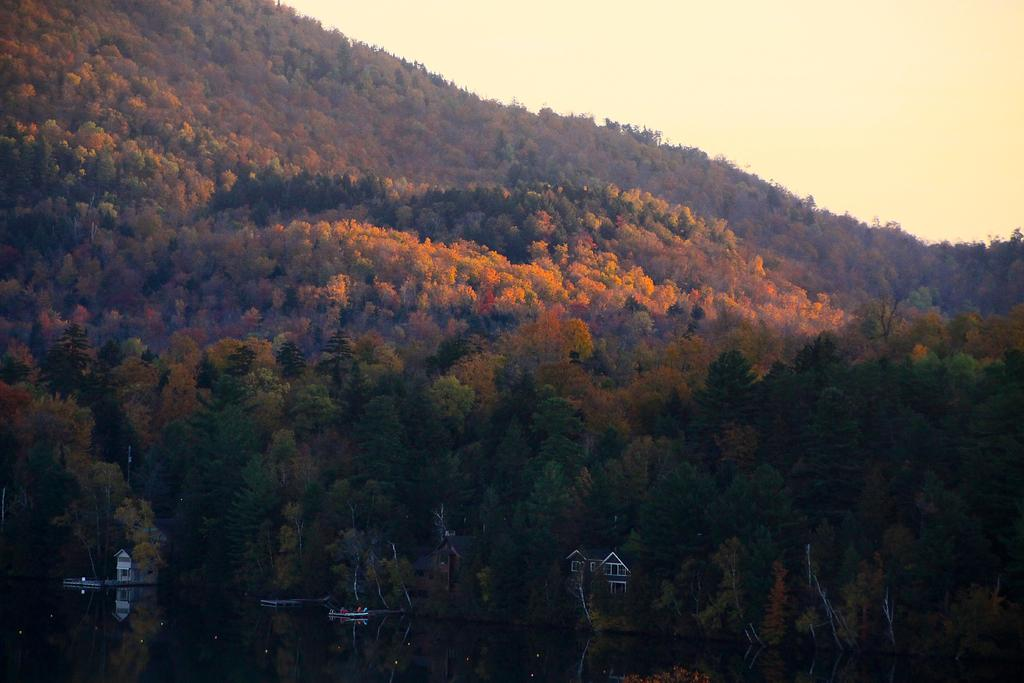What body of water is present in the image? There is a lake in the picture. What is located in the lake? There is a boat in the lake. What structures can be seen in the image? There are buildings in the picture. What type of vegetation is present in the image? There are trees in the picture. What geographical feature is visible in the background? There is a mountain in the picture. How many spiders are crawling on the boat in the image? There are no spiders present in the image; it only features a boat in the lake. What type of underwear is hanging on the tree in the image? There is no underwear present in the image; it only features trees and a mountain in the background. 